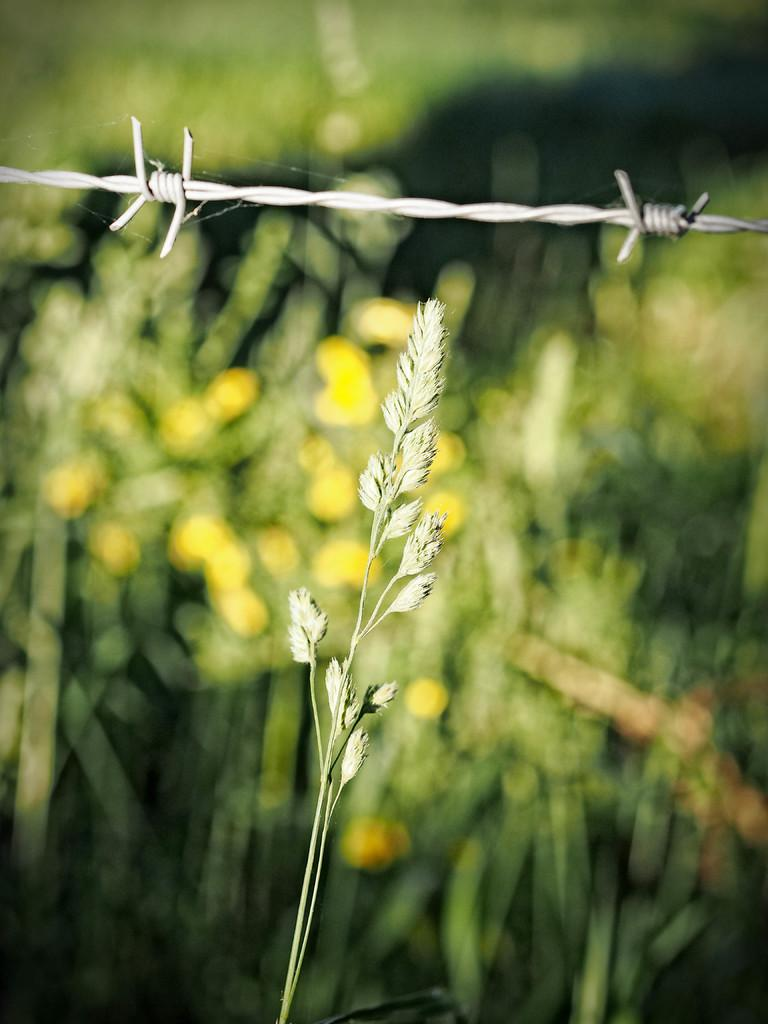What type of plant material is present in the image? There is a branch with leaves in the image. What other object can be seen in the image? There is an iron wire in the image. How would you describe the background of the image? The background of the image is blurred. What type of club does the person in the image belong to? There is no person present in the image, so it is not possible to determine what club they might belong to. 